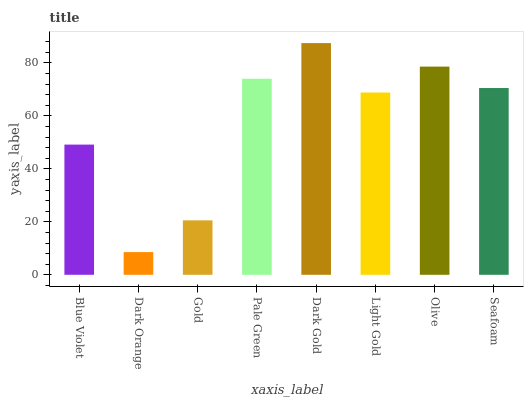Is Dark Orange the minimum?
Answer yes or no. Yes. Is Dark Gold the maximum?
Answer yes or no. Yes. Is Gold the minimum?
Answer yes or no. No. Is Gold the maximum?
Answer yes or no. No. Is Gold greater than Dark Orange?
Answer yes or no. Yes. Is Dark Orange less than Gold?
Answer yes or no. Yes. Is Dark Orange greater than Gold?
Answer yes or no. No. Is Gold less than Dark Orange?
Answer yes or no. No. Is Seafoam the high median?
Answer yes or no. Yes. Is Light Gold the low median?
Answer yes or no. Yes. Is Pale Green the high median?
Answer yes or no. No. Is Gold the low median?
Answer yes or no. No. 